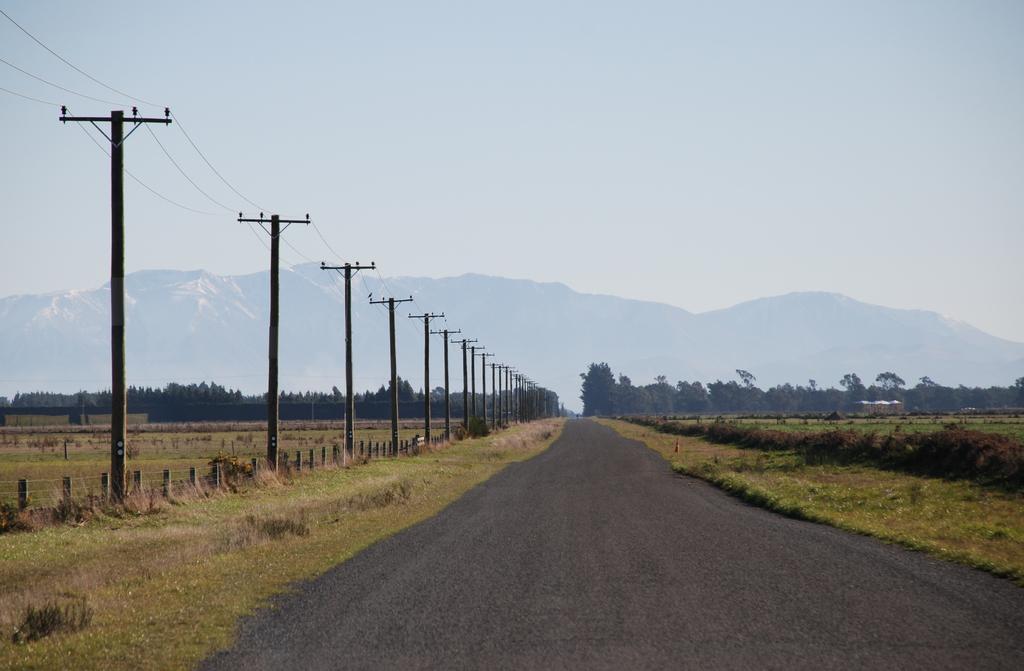Please provide a concise description of this image. In this image there is a road, on either side of the road there is grassland, on the left side there are current poles, in the background there are trees and a mountain. 